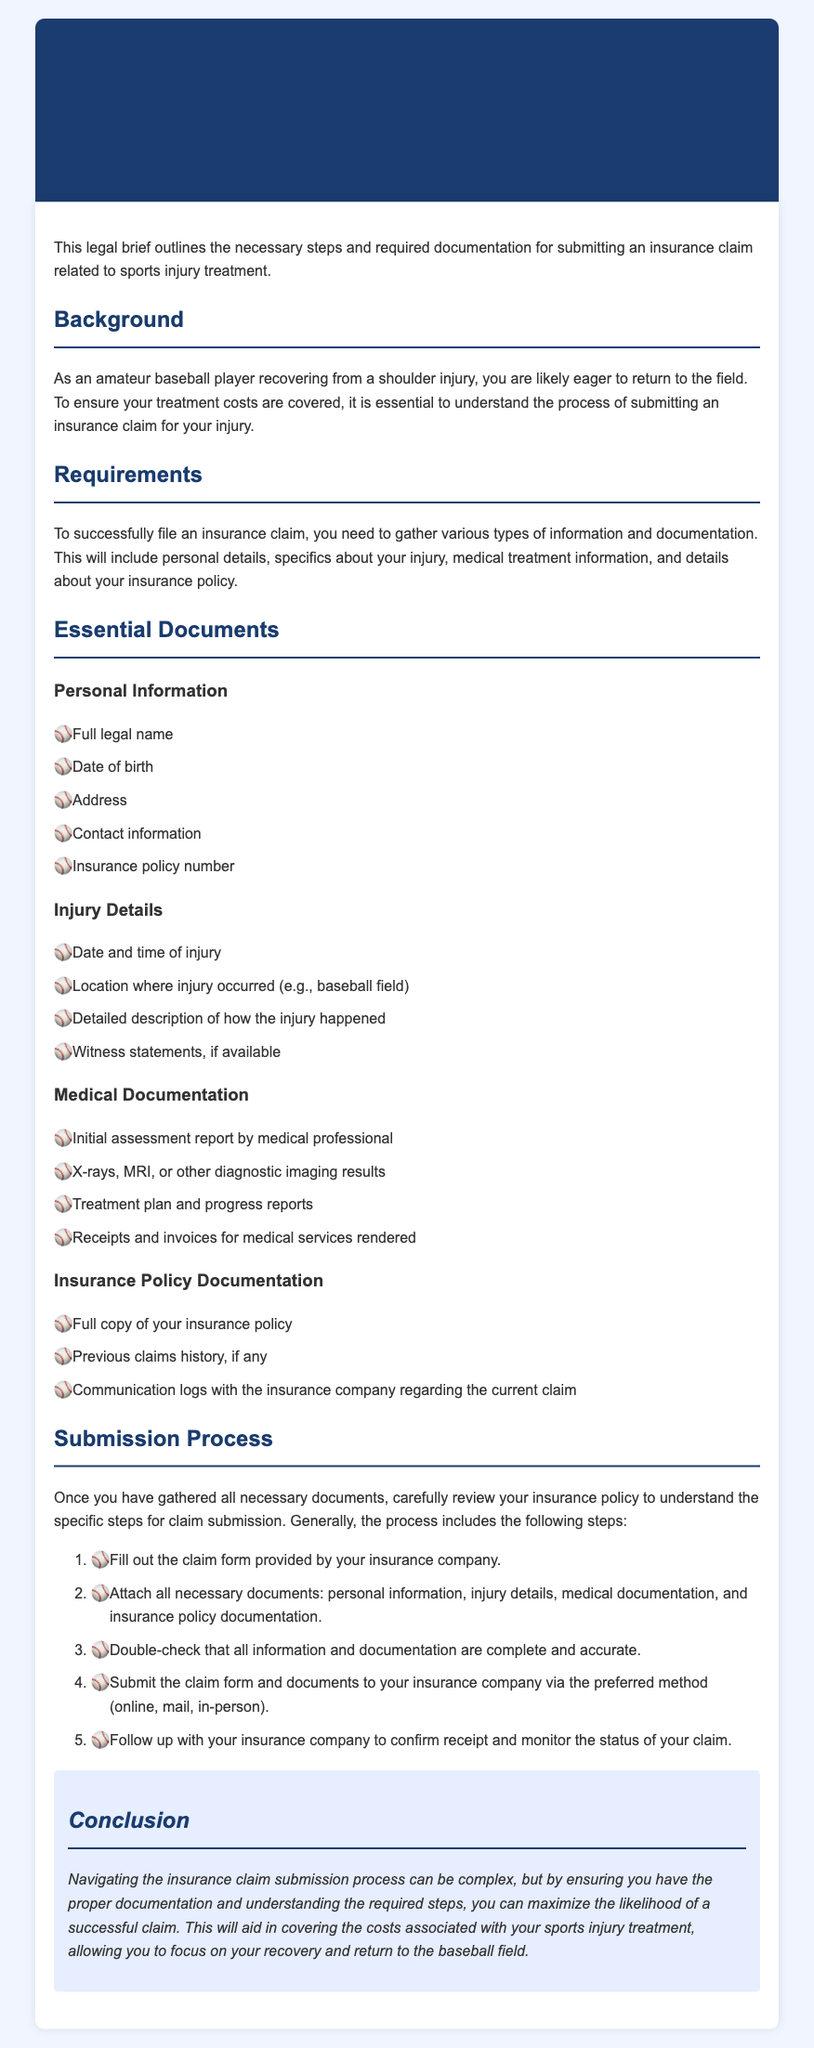What is the title of the document? The title is stated at the top of the document as the main heading.
Answer: Insurance Claim Submission for Sports Injury Treatment Who is the intended audience for this legal brief? The intended audience is described in the background section of the document.
Answer: Amateur baseball players What is one essential document related to personal information? The document lists various personal information requirements, and an example is explicitly mentioned.
Answer: Full legal name What is required to substantiate the injury details? The document presents specific items that need to be documented about the injury.
Answer: Detailed description of how the injury happened What is the first step in the submission process? The submission process outlines steps, and the first one is specifically listed.
Answer: Fill out the claim form How many types of documentation are specified under Essential Documents? The document categorizes documentation into four main types.
Answer: Four What should be done after submitting the claim? The document advises on a follow-up action to take after submission.
Answer: Follow up with your insurance company Why is understanding the submission process important? The conclusion highlights a significant aspect of the process and its impact.
Answer: Maximize the likelihood of a successful claim 